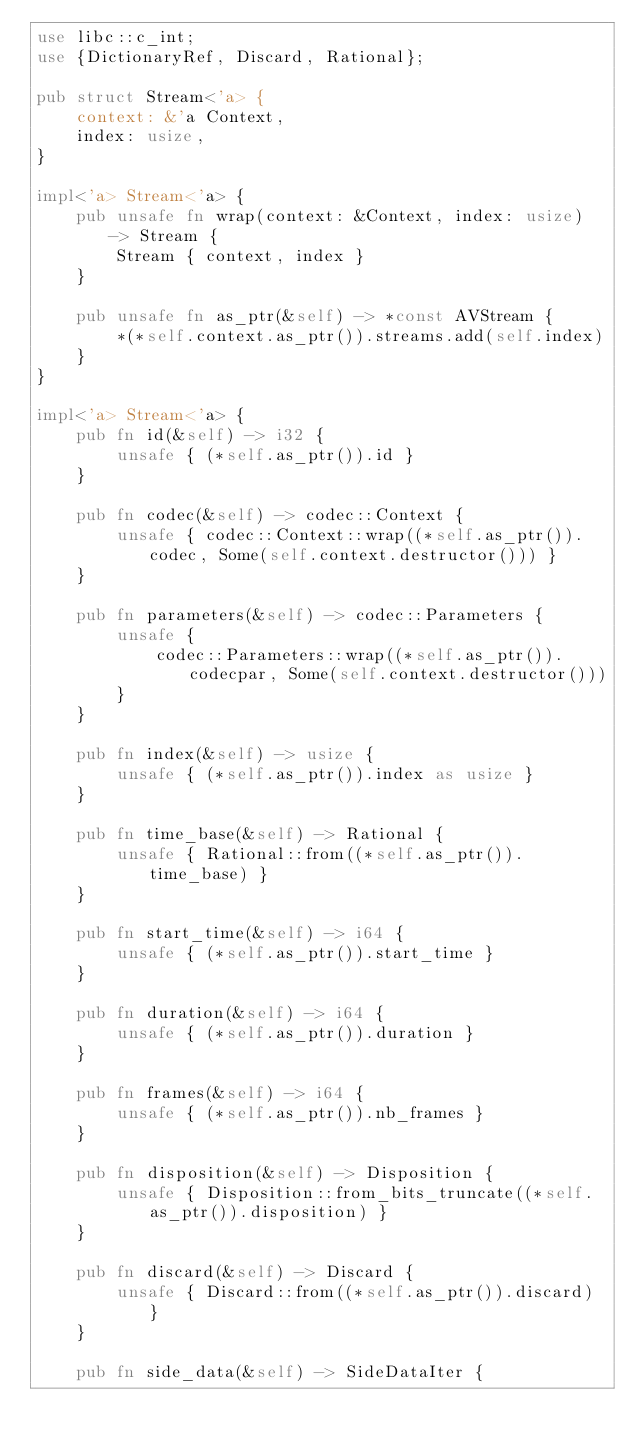Convert code to text. <code><loc_0><loc_0><loc_500><loc_500><_Rust_>use libc::c_int;
use {DictionaryRef, Discard, Rational};

pub struct Stream<'a> {
    context: &'a Context,
    index: usize,
}

impl<'a> Stream<'a> {
    pub unsafe fn wrap(context: &Context, index: usize) -> Stream {
        Stream { context, index }
    }

    pub unsafe fn as_ptr(&self) -> *const AVStream {
        *(*self.context.as_ptr()).streams.add(self.index)
    }
}

impl<'a> Stream<'a> {
    pub fn id(&self) -> i32 {
        unsafe { (*self.as_ptr()).id }
    }

    pub fn codec(&self) -> codec::Context {
        unsafe { codec::Context::wrap((*self.as_ptr()).codec, Some(self.context.destructor())) }
    }

    pub fn parameters(&self) -> codec::Parameters {
        unsafe {
            codec::Parameters::wrap((*self.as_ptr()).codecpar, Some(self.context.destructor()))
        }
    }

    pub fn index(&self) -> usize {
        unsafe { (*self.as_ptr()).index as usize }
    }

    pub fn time_base(&self) -> Rational {
        unsafe { Rational::from((*self.as_ptr()).time_base) }
    }

    pub fn start_time(&self) -> i64 {
        unsafe { (*self.as_ptr()).start_time }
    }

    pub fn duration(&self) -> i64 {
        unsafe { (*self.as_ptr()).duration }
    }

    pub fn frames(&self) -> i64 {
        unsafe { (*self.as_ptr()).nb_frames }
    }

    pub fn disposition(&self) -> Disposition {
        unsafe { Disposition::from_bits_truncate((*self.as_ptr()).disposition) }
    }

    pub fn discard(&self) -> Discard {
        unsafe { Discard::from((*self.as_ptr()).discard) }
    }

    pub fn side_data(&self) -> SideDataIter {</code> 